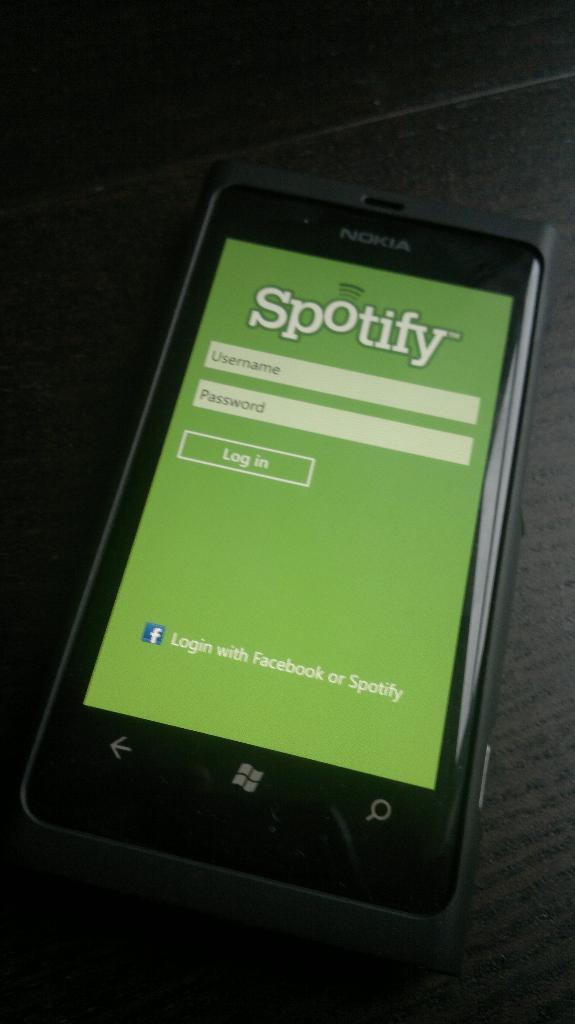What website can you use to login to the app?
Offer a terse response. Facebook. What app is this?
Your answer should be very brief. Spotify. 